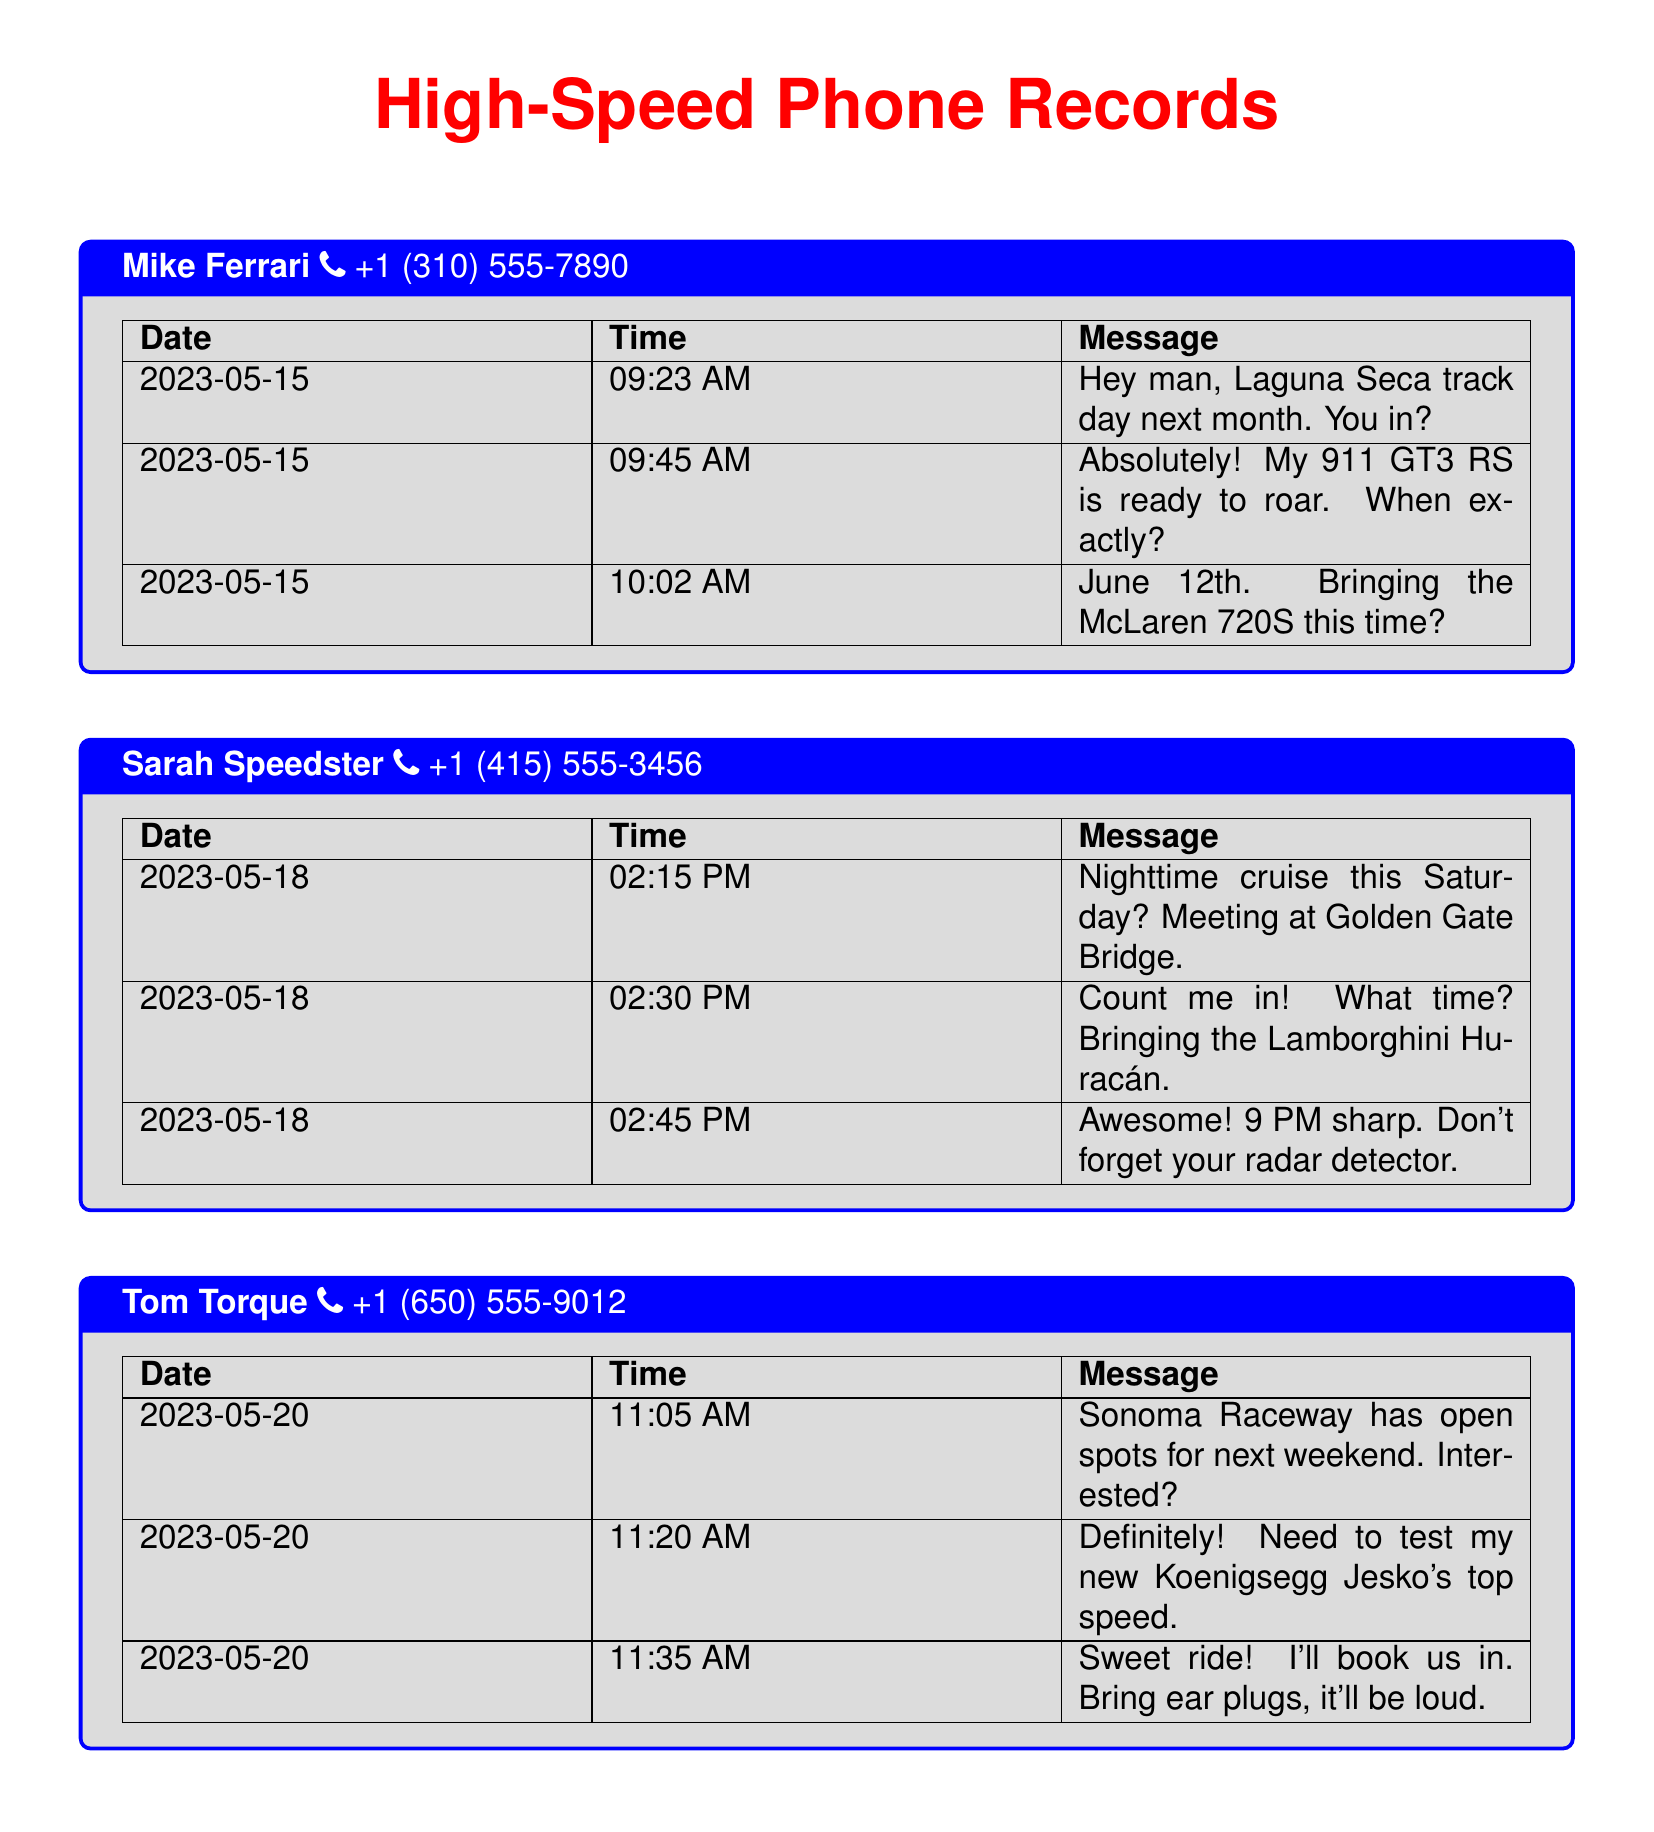What is the date of the Laguna Seca track day? The document states that the Laguna Seca track day is scheduled for June 12th.
Answer: June 12th What car is Mike Ferrari bringing to the Laguna Seca track day? Mike Ferrari mentions he is bringing his 911 GT3 RS to the track day.
Answer: 911 GT3 RS What time is the nighttime cruise meeting? The document specifies that the nighttime cruise is set to meet at 9 PM sharp.
Answer: 9 PM Which car does Sarah Speedster plan to bring for the nighttime cruise? Sarah Speedster states she will be bringing the Lamborghini Huracán for the cruise.
Answer: Lamborghini Huracán What is Tom Torque testing at Sonoma Raceway? Tom Torque mentions he needs to test his new Koenigsegg Jesko's top speed at the raceway.
Answer: Koenigsegg Jesko What event is scheduled for Sunday in the document? The document lists an exotic car meet at Cars and Coffee as the event for Sunday.
Answer: Exotic car meet at Cars and Coffee What time is the car meet at Santana Row? The document indicates that the meet at Santana Row is scheduled for 8 AM.
Answer: 8 AM Who is attending the exotic car meet with a new Bugatti? Lisa Leadfoot states she is debuting her new Bugatti Chiron Super Sport 300+ at the meet.
Answer: Bugatti Chiron Super Sport 300+ 